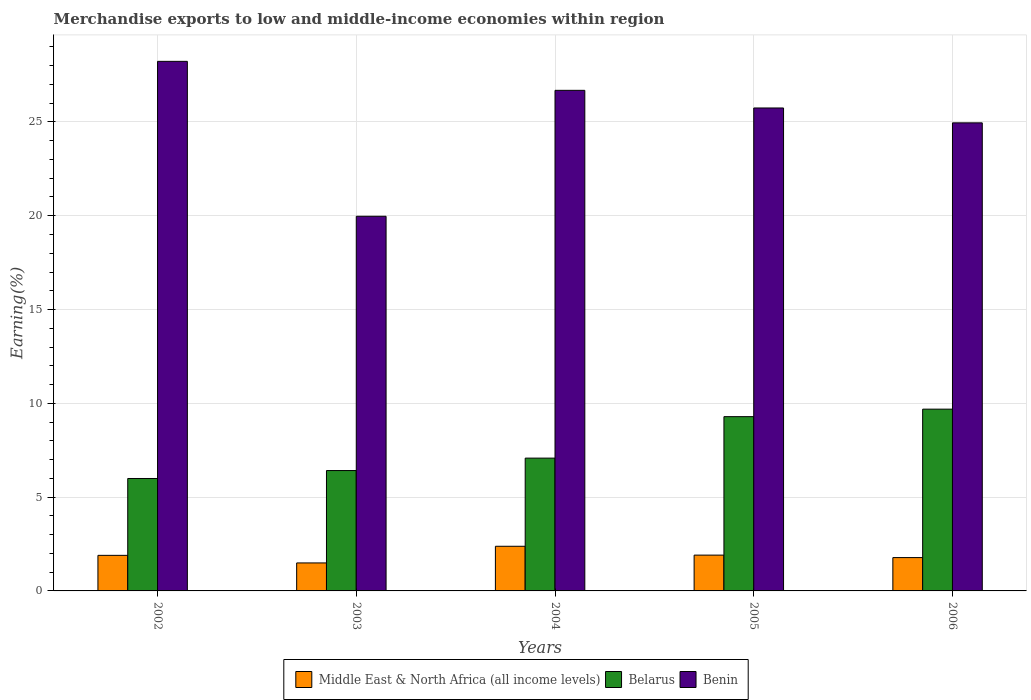How many different coloured bars are there?
Give a very brief answer. 3. How many groups of bars are there?
Provide a short and direct response. 5. Are the number of bars per tick equal to the number of legend labels?
Your answer should be very brief. Yes. Are the number of bars on each tick of the X-axis equal?
Provide a short and direct response. Yes. How many bars are there on the 1st tick from the left?
Provide a succinct answer. 3. What is the label of the 1st group of bars from the left?
Provide a succinct answer. 2002. What is the percentage of amount earned from merchandise exports in Belarus in 2005?
Your answer should be very brief. 9.29. Across all years, what is the maximum percentage of amount earned from merchandise exports in Middle East & North Africa (all income levels)?
Your response must be concise. 2.38. Across all years, what is the minimum percentage of amount earned from merchandise exports in Belarus?
Keep it short and to the point. 5.99. What is the total percentage of amount earned from merchandise exports in Middle East & North Africa (all income levels) in the graph?
Keep it short and to the point. 9.45. What is the difference between the percentage of amount earned from merchandise exports in Middle East & North Africa (all income levels) in 2004 and that in 2005?
Keep it short and to the point. 0.47. What is the difference between the percentage of amount earned from merchandise exports in Middle East & North Africa (all income levels) in 2003 and the percentage of amount earned from merchandise exports in Benin in 2006?
Keep it short and to the point. -23.46. What is the average percentage of amount earned from merchandise exports in Middle East & North Africa (all income levels) per year?
Your answer should be compact. 1.89. In the year 2004, what is the difference between the percentage of amount earned from merchandise exports in Middle East & North Africa (all income levels) and percentage of amount earned from merchandise exports in Belarus?
Offer a terse response. -4.7. In how many years, is the percentage of amount earned from merchandise exports in Belarus greater than 16 %?
Make the answer very short. 0. What is the ratio of the percentage of amount earned from merchandise exports in Belarus in 2002 to that in 2005?
Provide a short and direct response. 0.65. Is the percentage of amount earned from merchandise exports in Middle East & North Africa (all income levels) in 2003 less than that in 2005?
Keep it short and to the point. Yes. Is the difference between the percentage of amount earned from merchandise exports in Middle East & North Africa (all income levels) in 2003 and 2006 greater than the difference between the percentage of amount earned from merchandise exports in Belarus in 2003 and 2006?
Offer a very short reply. Yes. What is the difference between the highest and the second highest percentage of amount earned from merchandise exports in Middle East & North Africa (all income levels)?
Give a very brief answer. 0.47. What is the difference between the highest and the lowest percentage of amount earned from merchandise exports in Belarus?
Keep it short and to the point. 3.7. In how many years, is the percentage of amount earned from merchandise exports in Benin greater than the average percentage of amount earned from merchandise exports in Benin taken over all years?
Your answer should be compact. 3. Is the sum of the percentage of amount earned from merchandise exports in Benin in 2004 and 2006 greater than the maximum percentage of amount earned from merchandise exports in Middle East & North Africa (all income levels) across all years?
Provide a succinct answer. Yes. What does the 3rd bar from the left in 2005 represents?
Your answer should be compact. Benin. What does the 2nd bar from the right in 2006 represents?
Give a very brief answer. Belarus. Are all the bars in the graph horizontal?
Offer a very short reply. No. Does the graph contain any zero values?
Give a very brief answer. No. Does the graph contain grids?
Your answer should be very brief. Yes. How many legend labels are there?
Offer a terse response. 3. How are the legend labels stacked?
Your answer should be very brief. Horizontal. What is the title of the graph?
Keep it short and to the point. Merchandise exports to low and middle-income economies within region. Does "Turks and Caicos Islands" appear as one of the legend labels in the graph?
Provide a succinct answer. No. What is the label or title of the X-axis?
Offer a very short reply. Years. What is the label or title of the Y-axis?
Give a very brief answer. Earning(%). What is the Earning(%) of Middle East & North Africa (all income levels) in 2002?
Your answer should be very brief. 1.9. What is the Earning(%) of Belarus in 2002?
Provide a succinct answer. 5.99. What is the Earning(%) of Benin in 2002?
Make the answer very short. 28.23. What is the Earning(%) in Middle East & North Africa (all income levels) in 2003?
Your answer should be compact. 1.49. What is the Earning(%) of Belarus in 2003?
Ensure brevity in your answer.  6.42. What is the Earning(%) in Benin in 2003?
Your answer should be compact. 19.97. What is the Earning(%) in Middle East & North Africa (all income levels) in 2004?
Your response must be concise. 2.38. What is the Earning(%) in Belarus in 2004?
Your response must be concise. 7.08. What is the Earning(%) in Benin in 2004?
Keep it short and to the point. 26.68. What is the Earning(%) of Middle East & North Africa (all income levels) in 2005?
Your answer should be very brief. 1.91. What is the Earning(%) in Belarus in 2005?
Ensure brevity in your answer.  9.29. What is the Earning(%) in Benin in 2005?
Give a very brief answer. 25.74. What is the Earning(%) of Middle East & North Africa (all income levels) in 2006?
Provide a succinct answer. 1.78. What is the Earning(%) of Belarus in 2006?
Make the answer very short. 9.69. What is the Earning(%) of Benin in 2006?
Offer a very short reply. 24.95. Across all years, what is the maximum Earning(%) in Middle East & North Africa (all income levels)?
Ensure brevity in your answer.  2.38. Across all years, what is the maximum Earning(%) of Belarus?
Keep it short and to the point. 9.69. Across all years, what is the maximum Earning(%) of Benin?
Provide a succinct answer. 28.23. Across all years, what is the minimum Earning(%) of Middle East & North Africa (all income levels)?
Offer a terse response. 1.49. Across all years, what is the minimum Earning(%) of Belarus?
Give a very brief answer. 5.99. Across all years, what is the minimum Earning(%) in Benin?
Your answer should be very brief. 19.97. What is the total Earning(%) of Middle East & North Africa (all income levels) in the graph?
Provide a succinct answer. 9.45. What is the total Earning(%) in Belarus in the graph?
Provide a succinct answer. 38.47. What is the total Earning(%) of Benin in the graph?
Provide a succinct answer. 125.58. What is the difference between the Earning(%) of Middle East & North Africa (all income levels) in 2002 and that in 2003?
Offer a very short reply. 0.4. What is the difference between the Earning(%) in Belarus in 2002 and that in 2003?
Give a very brief answer. -0.42. What is the difference between the Earning(%) in Benin in 2002 and that in 2003?
Ensure brevity in your answer.  8.26. What is the difference between the Earning(%) in Middle East & North Africa (all income levels) in 2002 and that in 2004?
Offer a terse response. -0.48. What is the difference between the Earning(%) of Belarus in 2002 and that in 2004?
Your response must be concise. -1.09. What is the difference between the Earning(%) in Benin in 2002 and that in 2004?
Provide a succinct answer. 1.55. What is the difference between the Earning(%) of Middle East & North Africa (all income levels) in 2002 and that in 2005?
Ensure brevity in your answer.  -0.01. What is the difference between the Earning(%) of Belarus in 2002 and that in 2005?
Provide a short and direct response. -3.3. What is the difference between the Earning(%) of Benin in 2002 and that in 2005?
Give a very brief answer. 2.49. What is the difference between the Earning(%) in Middle East & North Africa (all income levels) in 2002 and that in 2006?
Ensure brevity in your answer.  0.12. What is the difference between the Earning(%) of Belarus in 2002 and that in 2006?
Your answer should be very brief. -3.7. What is the difference between the Earning(%) of Benin in 2002 and that in 2006?
Your answer should be very brief. 3.28. What is the difference between the Earning(%) of Middle East & North Africa (all income levels) in 2003 and that in 2004?
Provide a succinct answer. -0.89. What is the difference between the Earning(%) in Belarus in 2003 and that in 2004?
Provide a succinct answer. -0.66. What is the difference between the Earning(%) in Benin in 2003 and that in 2004?
Ensure brevity in your answer.  -6.71. What is the difference between the Earning(%) in Middle East & North Africa (all income levels) in 2003 and that in 2005?
Keep it short and to the point. -0.42. What is the difference between the Earning(%) of Belarus in 2003 and that in 2005?
Give a very brief answer. -2.87. What is the difference between the Earning(%) of Benin in 2003 and that in 2005?
Provide a short and direct response. -5.77. What is the difference between the Earning(%) of Middle East & North Africa (all income levels) in 2003 and that in 2006?
Provide a short and direct response. -0.29. What is the difference between the Earning(%) of Belarus in 2003 and that in 2006?
Offer a very short reply. -3.27. What is the difference between the Earning(%) of Benin in 2003 and that in 2006?
Provide a short and direct response. -4.98. What is the difference between the Earning(%) in Middle East & North Africa (all income levels) in 2004 and that in 2005?
Ensure brevity in your answer.  0.47. What is the difference between the Earning(%) of Belarus in 2004 and that in 2005?
Provide a short and direct response. -2.21. What is the difference between the Earning(%) in Benin in 2004 and that in 2005?
Make the answer very short. 0.94. What is the difference between the Earning(%) in Middle East & North Africa (all income levels) in 2004 and that in 2006?
Keep it short and to the point. 0.6. What is the difference between the Earning(%) in Belarus in 2004 and that in 2006?
Make the answer very short. -2.61. What is the difference between the Earning(%) in Benin in 2004 and that in 2006?
Your answer should be compact. 1.73. What is the difference between the Earning(%) of Middle East & North Africa (all income levels) in 2005 and that in 2006?
Provide a short and direct response. 0.13. What is the difference between the Earning(%) of Belarus in 2005 and that in 2006?
Your response must be concise. -0.4. What is the difference between the Earning(%) of Benin in 2005 and that in 2006?
Provide a short and direct response. 0.79. What is the difference between the Earning(%) in Middle East & North Africa (all income levels) in 2002 and the Earning(%) in Belarus in 2003?
Provide a succinct answer. -4.52. What is the difference between the Earning(%) in Middle East & North Africa (all income levels) in 2002 and the Earning(%) in Benin in 2003?
Your answer should be compact. -18.07. What is the difference between the Earning(%) of Belarus in 2002 and the Earning(%) of Benin in 2003?
Make the answer very short. -13.98. What is the difference between the Earning(%) in Middle East & North Africa (all income levels) in 2002 and the Earning(%) in Belarus in 2004?
Make the answer very short. -5.18. What is the difference between the Earning(%) in Middle East & North Africa (all income levels) in 2002 and the Earning(%) in Benin in 2004?
Offer a terse response. -24.79. What is the difference between the Earning(%) in Belarus in 2002 and the Earning(%) in Benin in 2004?
Offer a very short reply. -20.69. What is the difference between the Earning(%) in Middle East & North Africa (all income levels) in 2002 and the Earning(%) in Belarus in 2005?
Offer a very short reply. -7.39. What is the difference between the Earning(%) of Middle East & North Africa (all income levels) in 2002 and the Earning(%) of Benin in 2005?
Your answer should be very brief. -23.85. What is the difference between the Earning(%) in Belarus in 2002 and the Earning(%) in Benin in 2005?
Your response must be concise. -19.75. What is the difference between the Earning(%) of Middle East & North Africa (all income levels) in 2002 and the Earning(%) of Belarus in 2006?
Offer a very short reply. -7.79. What is the difference between the Earning(%) of Middle East & North Africa (all income levels) in 2002 and the Earning(%) of Benin in 2006?
Keep it short and to the point. -23.05. What is the difference between the Earning(%) in Belarus in 2002 and the Earning(%) in Benin in 2006?
Ensure brevity in your answer.  -18.96. What is the difference between the Earning(%) in Middle East & North Africa (all income levels) in 2003 and the Earning(%) in Belarus in 2004?
Your answer should be compact. -5.59. What is the difference between the Earning(%) of Middle East & North Africa (all income levels) in 2003 and the Earning(%) of Benin in 2004?
Offer a very short reply. -25.19. What is the difference between the Earning(%) in Belarus in 2003 and the Earning(%) in Benin in 2004?
Your answer should be very brief. -20.27. What is the difference between the Earning(%) in Middle East & North Africa (all income levels) in 2003 and the Earning(%) in Belarus in 2005?
Keep it short and to the point. -7.8. What is the difference between the Earning(%) of Middle East & North Africa (all income levels) in 2003 and the Earning(%) of Benin in 2005?
Offer a terse response. -24.25. What is the difference between the Earning(%) in Belarus in 2003 and the Earning(%) in Benin in 2005?
Give a very brief answer. -19.33. What is the difference between the Earning(%) of Middle East & North Africa (all income levels) in 2003 and the Earning(%) of Belarus in 2006?
Make the answer very short. -8.2. What is the difference between the Earning(%) in Middle East & North Africa (all income levels) in 2003 and the Earning(%) in Benin in 2006?
Keep it short and to the point. -23.46. What is the difference between the Earning(%) in Belarus in 2003 and the Earning(%) in Benin in 2006?
Keep it short and to the point. -18.54. What is the difference between the Earning(%) of Middle East & North Africa (all income levels) in 2004 and the Earning(%) of Belarus in 2005?
Your response must be concise. -6.91. What is the difference between the Earning(%) in Middle East & North Africa (all income levels) in 2004 and the Earning(%) in Benin in 2005?
Ensure brevity in your answer.  -23.36. What is the difference between the Earning(%) in Belarus in 2004 and the Earning(%) in Benin in 2005?
Keep it short and to the point. -18.67. What is the difference between the Earning(%) of Middle East & North Africa (all income levels) in 2004 and the Earning(%) of Belarus in 2006?
Ensure brevity in your answer.  -7.31. What is the difference between the Earning(%) of Middle East & North Africa (all income levels) in 2004 and the Earning(%) of Benin in 2006?
Offer a terse response. -22.57. What is the difference between the Earning(%) of Belarus in 2004 and the Earning(%) of Benin in 2006?
Make the answer very short. -17.87. What is the difference between the Earning(%) of Middle East & North Africa (all income levels) in 2005 and the Earning(%) of Belarus in 2006?
Provide a succinct answer. -7.78. What is the difference between the Earning(%) of Middle East & North Africa (all income levels) in 2005 and the Earning(%) of Benin in 2006?
Your answer should be compact. -23.04. What is the difference between the Earning(%) of Belarus in 2005 and the Earning(%) of Benin in 2006?
Provide a short and direct response. -15.66. What is the average Earning(%) of Middle East & North Africa (all income levels) per year?
Your response must be concise. 1.89. What is the average Earning(%) of Belarus per year?
Give a very brief answer. 7.69. What is the average Earning(%) of Benin per year?
Offer a terse response. 25.12. In the year 2002, what is the difference between the Earning(%) of Middle East & North Africa (all income levels) and Earning(%) of Belarus?
Your answer should be very brief. -4.1. In the year 2002, what is the difference between the Earning(%) of Middle East & North Africa (all income levels) and Earning(%) of Benin?
Make the answer very short. -26.33. In the year 2002, what is the difference between the Earning(%) of Belarus and Earning(%) of Benin?
Keep it short and to the point. -22.24. In the year 2003, what is the difference between the Earning(%) in Middle East & North Africa (all income levels) and Earning(%) in Belarus?
Ensure brevity in your answer.  -4.92. In the year 2003, what is the difference between the Earning(%) in Middle East & North Africa (all income levels) and Earning(%) in Benin?
Your answer should be compact. -18.48. In the year 2003, what is the difference between the Earning(%) of Belarus and Earning(%) of Benin?
Make the answer very short. -13.56. In the year 2004, what is the difference between the Earning(%) of Middle East & North Africa (all income levels) and Earning(%) of Belarus?
Make the answer very short. -4.7. In the year 2004, what is the difference between the Earning(%) in Middle East & North Africa (all income levels) and Earning(%) in Benin?
Provide a short and direct response. -24.3. In the year 2004, what is the difference between the Earning(%) of Belarus and Earning(%) of Benin?
Provide a short and direct response. -19.61. In the year 2005, what is the difference between the Earning(%) in Middle East & North Africa (all income levels) and Earning(%) in Belarus?
Your answer should be very brief. -7.38. In the year 2005, what is the difference between the Earning(%) in Middle East & North Africa (all income levels) and Earning(%) in Benin?
Keep it short and to the point. -23.84. In the year 2005, what is the difference between the Earning(%) in Belarus and Earning(%) in Benin?
Your answer should be very brief. -16.45. In the year 2006, what is the difference between the Earning(%) of Middle East & North Africa (all income levels) and Earning(%) of Belarus?
Ensure brevity in your answer.  -7.91. In the year 2006, what is the difference between the Earning(%) of Middle East & North Africa (all income levels) and Earning(%) of Benin?
Provide a short and direct response. -23.17. In the year 2006, what is the difference between the Earning(%) in Belarus and Earning(%) in Benin?
Provide a short and direct response. -15.26. What is the ratio of the Earning(%) of Middle East & North Africa (all income levels) in 2002 to that in 2003?
Your answer should be very brief. 1.27. What is the ratio of the Earning(%) of Belarus in 2002 to that in 2003?
Keep it short and to the point. 0.93. What is the ratio of the Earning(%) of Benin in 2002 to that in 2003?
Ensure brevity in your answer.  1.41. What is the ratio of the Earning(%) in Middle East & North Africa (all income levels) in 2002 to that in 2004?
Provide a succinct answer. 0.8. What is the ratio of the Earning(%) in Belarus in 2002 to that in 2004?
Keep it short and to the point. 0.85. What is the ratio of the Earning(%) in Benin in 2002 to that in 2004?
Provide a succinct answer. 1.06. What is the ratio of the Earning(%) of Middle East & North Africa (all income levels) in 2002 to that in 2005?
Your answer should be compact. 0.99. What is the ratio of the Earning(%) of Belarus in 2002 to that in 2005?
Ensure brevity in your answer.  0.65. What is the ratio of the Earning(%) of Benin in 2002 to that in 2005?
Your answer should be very brief. 1.1. What is the ratio of the Earning(%) in Middle East & North Africa (all income levels) in 2002 to that in 2006?
Your response must be concise. 1.07. What is the ratio of the Earning(%) of Belarus in 2002 to that in 2006?
Keep it short and to the point. 0.62. What is the ratio of the Earning(%) of Benin in 2002 to that in 2006?
Give a very brief answer. 1.13. What is the ratio of the Earning(%) of Middle East & North Africa (all income levels) in 2003 to that in 2004?
Make the answer very short. 0.63. What is the ratio of the Earning(%) of Belarus in 2003 to that in 2004?
Your response must be concise. 0.91. What is the ratio of the Earning(%) of Benin in 2003 to that in 2004?
Keep it short and to the point. 0.75. What is the ratio of the Earning(%) in Middle East & North Africa (all income levels) in 2003 to that in 2005?
Provide a succinct answer. 0.78. What is the ratio of the Earning(%) in Belarus in 2003 to that in 2005?
Your answer should be compact. 0.69. What is the ratio of the Earning(%) of Benin in 2003 to that in 2005?
Give a very brief answer. 0.78. What is the ratio of the Earning(%) in Middle East & North Africa (all income levels) in 2003 to that in 2006?
Make the answer very short. 0.84. What is the ratio of the Earning(%) of Belarus in 2003 to that in 2006?
Offer a terse response. 0.66. What is the ratio of the Earning(%) of Benin in 2003 to that in 2006?
Your answer should be very brief. 0.8. What is the ratio of the Earning(%) in Middle East & North Africa (all income levels) in 2004 to that in 2005?
Give a very brief answer. 1.25. What is the ratio of the Earning(%) in Belarus in 2004 to that in 2005?
Provide a succinct answer. 0.76. What is the ratio of the Earning(%) in Benin in 2004 to that in 2005?
Give a very brief answer. 1.04. What is the ratio of the Earning(%) of Middle East & North Africa (all income levels) in 2004 to that in 2006?
Provide a succinct answer. 1.34. What is the ratio of the Earning(%) in Belarus in 2004 to that in 2006?
Offer a very short reply. 0.73. What is the ratio of the Earning(%) of Benin in 2004 to that in 2006?
Provide a short and direct response. 1.07. What is the ratio of the Earning(%) in Middle East & North Africa (all income levels) in 2005 to that in 2006?
Make the answer very short. 1.07. What is the ratio of the Earning(%) of Belarus in 2005 to that in 2006?
Keep it short and to the point. 0.96. What is the ratio of the Earning(%) in Benin in 2005 to that in 2006?
Offer a terse response. 1.03. What is the difference between the highest and the second highest Earning(%) in Middle East & North Africa (all income levels)?
Your response must be concise. 0.47. What is the difference between the highest and the second highest Earning(%) in Belarus?
Your answer should be compact. 0.4. What is the difference between the highest and the second highest Earning(%) in Benin?
Offer a terse response. 1.55. What is the difference between the highest and the lowest Earning(%) of Middle East & North Africa (all income levels)?
Ensure brevity in your answer.  0.89. What is the difference between the highest and the lowest Earning(%) in Belarus?
Offer a terse response. 3.7. What is the difference between the highest and the lowest Earning(%) in Benin?
Give a very brief answer. 8.26. 